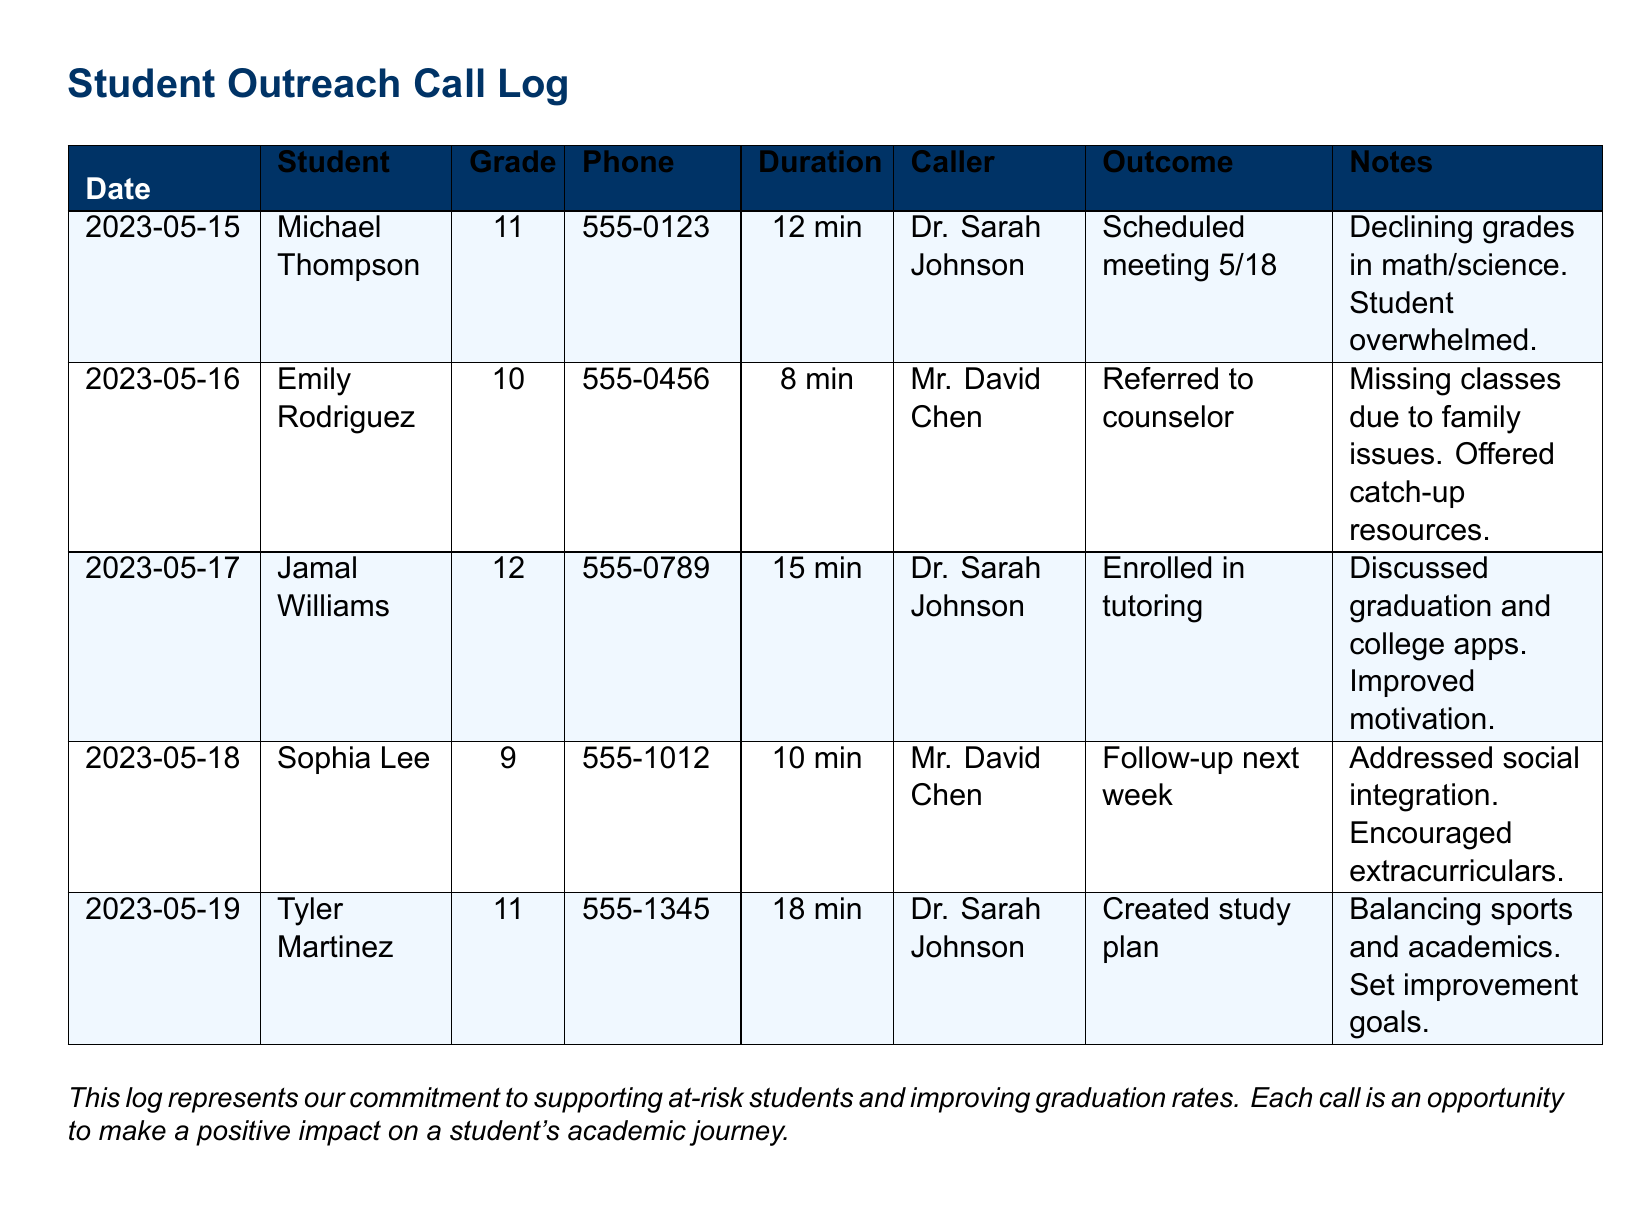What is the duration of the call with Michael Thompson? The duration of the call is listed in minutes next to his name, which is 12 minutes.
Answer: 12 min Who called Emily Rodriguez? The caller's name is found in the "Caller" column corresponding to Emily Rodriguez's entry.
Answer: Mr. David Chen What outcome was achieved after the call with Jamal Williams? The outcome is stated clearly in the "Outcome" column next to Jamal Williams' entry, which indicates he was enrolled in tutoring.
Answer: Enrolled in tutoring Which student discussed social integration during their call? The student associated with social integration can be found based on the notes in the relevant entry.
Answer: Sophia Lee What date was the call made to Tyler Martinez? The date of the call is provided in the first column under Tyler Martinez's entry.
Answer: 2023-05-19 How many minutes did the call with Jamal Williams last? The call duration can be found in the "Duration" column next to his name, which specifies the length of the call.
Answer: 15 min What grade is Michael Thompson in? His grade is specified in the "Grade" column corresponding to his name.
Answer: 11 What was the main reason for Emily Rodriguez's call? The reason is detailed in the notes section for her entry, referring to her missing classes due to family issues.
Answer: Family issues 